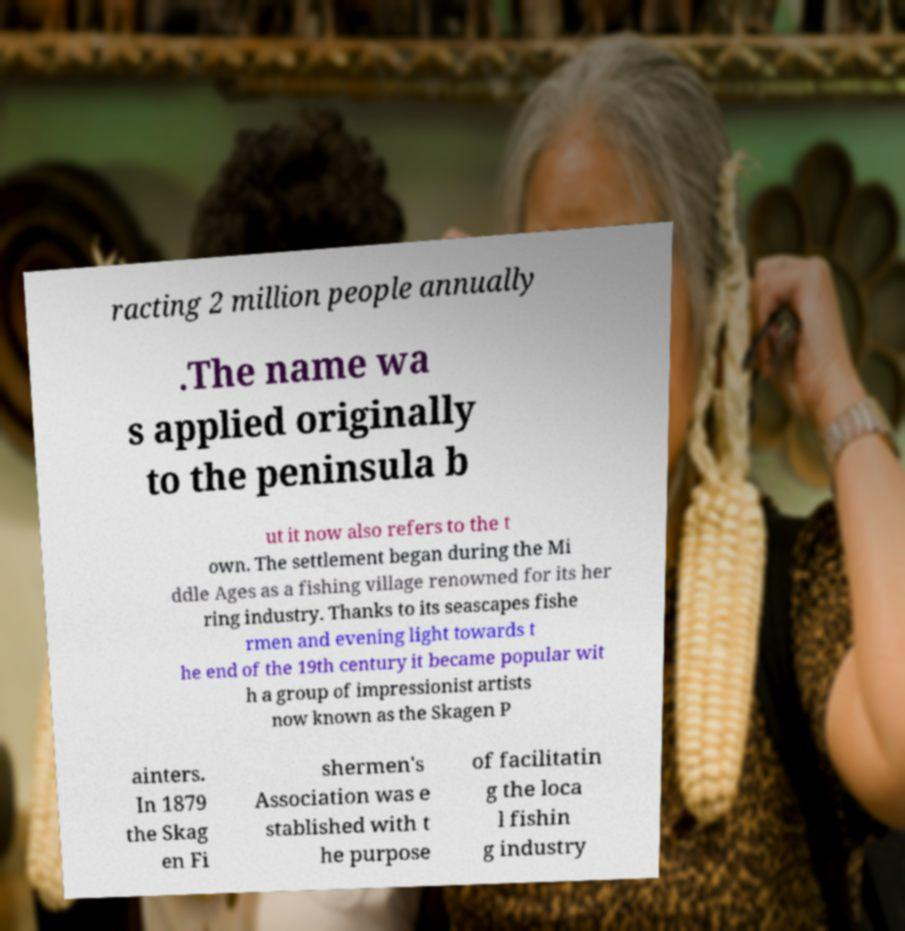What messages or text are displayed in this image? I need them in a readable, typed format. racting 2 million people annually .The name wa s applied originally to the peninsula b ut it now also refers to the t own. The settlement began during the Mi ddle Ages as a fishing village renowned for its her ring industry. Thanks to its seascapes fishe rmen and evening light towards t he end of the 19th century it became popular wit h a group of impressionist artists now known as the Skagen P ainters. In 1879 the Skag en Fi shermen's Association was e stablished with t he purpose of facilitatin g the loca l fishin g industry 